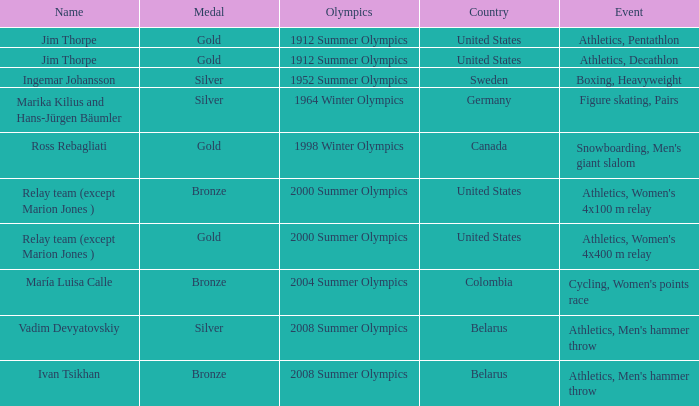What is the event in the 2000 summer olympics with a bronze medal? Athletics, Women's 4x100 m relay. 